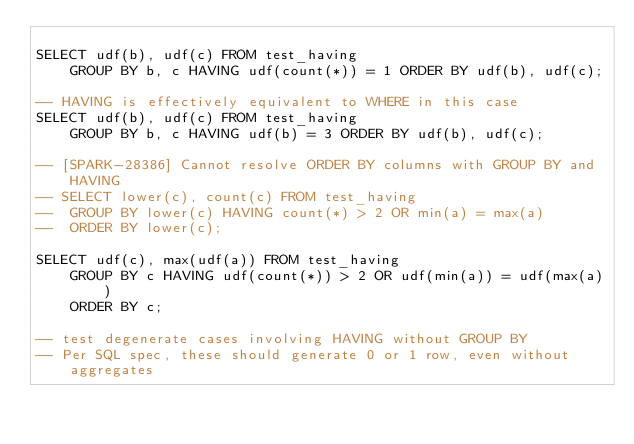Convert code to text. <code><loc_0><loc_0><loc_500><loc_500><_SQL_>
SELECT udf(b), udf(c) FROM test_having
	GROUP BY b, c HAVING udf(count(*)) = 1 ORDER BY udf(b), udf(c);

-- HAVING is effectively equivalent to WHERE in this case
SELECT udf(b), udf(c) FROM test_having
	GROUP BY b, c HAVING udf(b) = 3 ORDER BY udf(b), udf(c);

-- [SPARK-28386] Cannot resolve ORDER BY columns with GROUP BY and HAVING
-- SELECT lower(c), count(c) FROM test_having
-- 	GROUP BY lower(c) HAVING count(*) > 2 OR min(a) = max(a)
-- 	ORDER BY lower(c);

SELECT udf(c), max(udf(a)) FROM test_having
	GROUP BY c HAVING udf(count(*)) > 2 OR udf(min(a)) = udf(max(a))
	ORDER BY c;

-- test degenerate cases involving HAVING without GROUP BY
-- Per SQL spec, these should generate 0 or 1 row, even without aggregates
</code> 